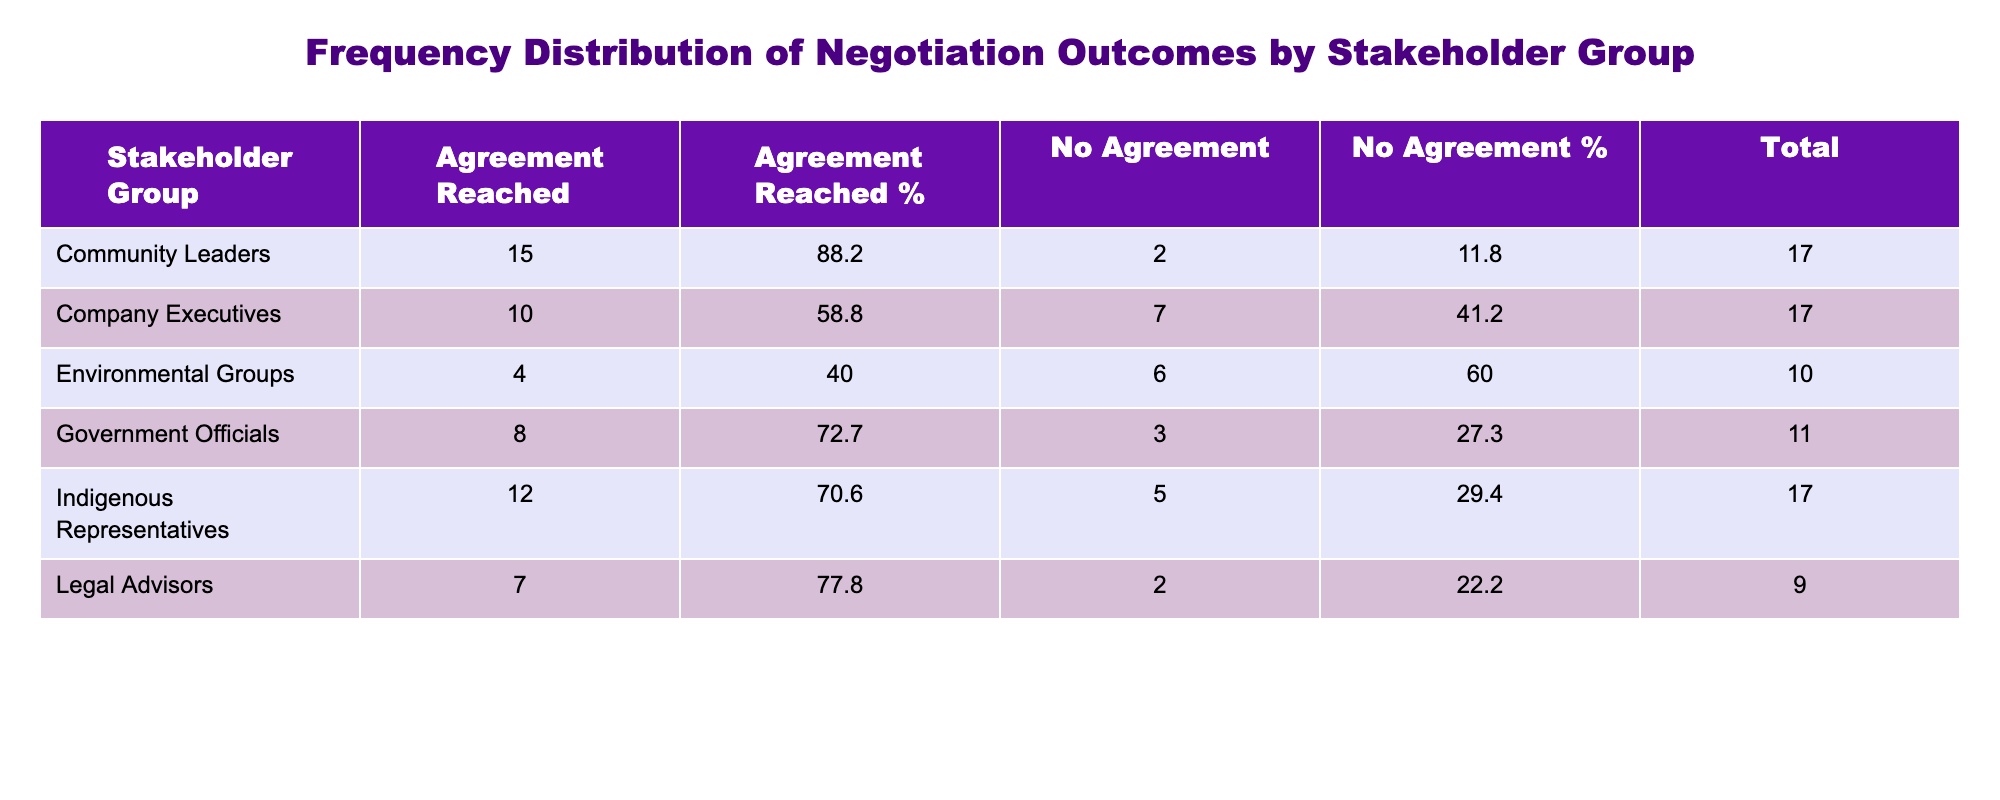What is the total number of agreements reached by Community Leaders? The total agreements reached by Community Leaders is found in the "Agreement Reached" column for that group. Looking at the table, it shows the count as 15.
Answer: 15 How many indigenous representatives were involved in negotiations where no agreement was reached? To find this, we look at the "No Agreement" column for Indigenous Representatives. The count is listed as 5 in the table.
Answer: 5 Which stakeholder group had the highest count of agreements reached? By comparing the "Agreement Reached" counts across all groups, Community Leaders have the highest count at 15. No other group reached that number.
Answer: Community Leaders What is the total number of stakeholders that reached agreement? To find the total, we add up the counts from the "Agreement Reached" column for all groups: 12 (Indigenous) + 10 (Company) + 8 (Government) + 15 (Community Leaders) + 4 (Environmental) + 7 (Legal) = 56.
Answer: 56 Is it true that Government Officials had more no agreements than Environmental Groups? Looking at the "No Agreement" column, Government Officials had 3, whereas Environmental Groups had 6. Thus, the statement is false.
Answer: No What percentage of agreements reached by Company Executives does their total represent among all agreements? First, total agreements reached is 56. Company Executives had 10 agreements reached. The percentage is (10/56)*100, which is approximately 17.9%.
Answer: 17.9% By what percentage did agreements outnumber no agreements for Indigenous Representatives? Indigenous Representatives had 12 agreements and 5 no agreements. The difference is 12 - 5 = 7. To find the percentage difference relative to no agreements: (7/5)*100 = 140%.
Answer: 140% Which group had the least number of agreements reached? Looking at the "Agreement Reached" counts, Environmental Groups had the least with 4 agreements. No other groups had fewer than this.
Answer: Environmental Groups What is the average number of no agreements across all stakeholder groups? To calculate the average of no agreements, we look at the counts: 5 (Indigenous) + 7 (Company) + 3 (Government) + 2 (Community Leaders) + 6 (Environmental) + 2 (Legal) = 25. There are 6 groups, so the average is 25/6, which is approximately 4.2.
Answer: 4.2 